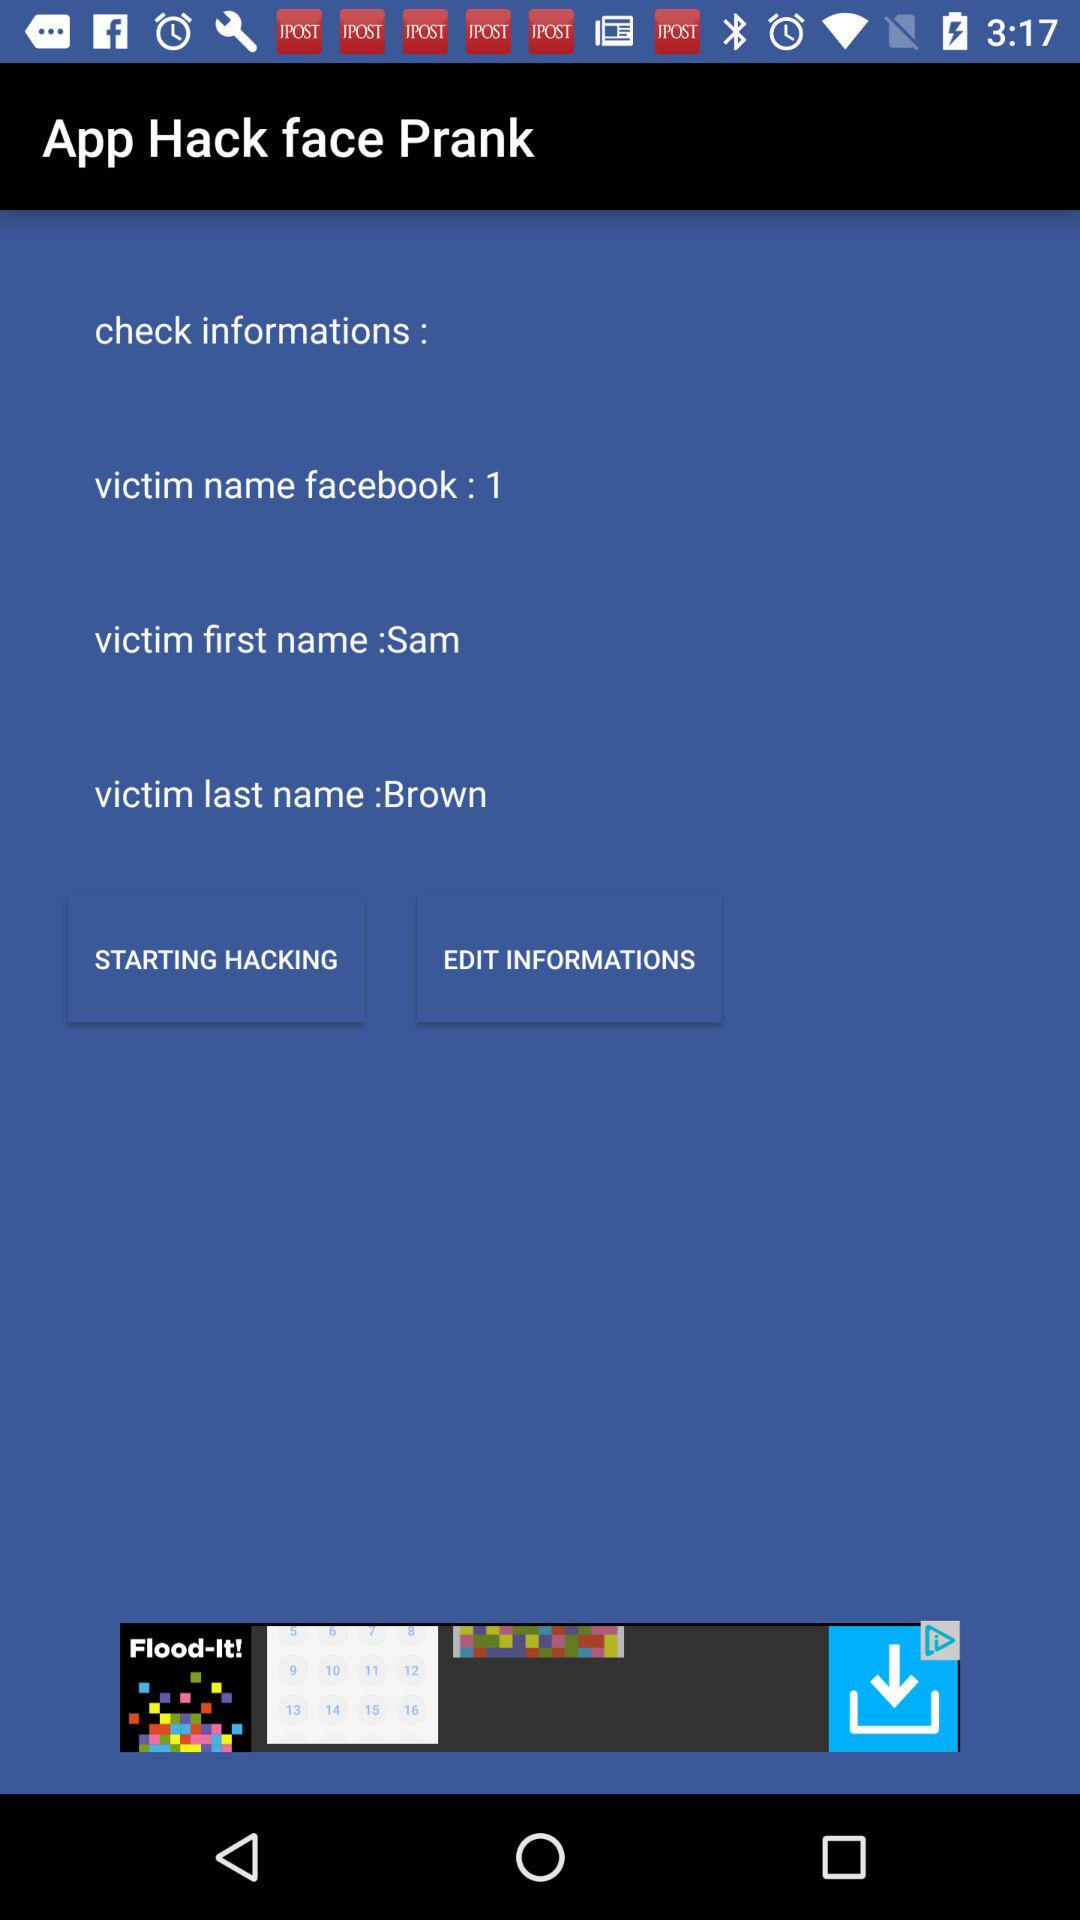What's the full user name? The full user name is Sam Brown. 